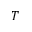Convert formula to latex. <formula><loc_0><loc_0><loc_500><loc_500>T</formula> 